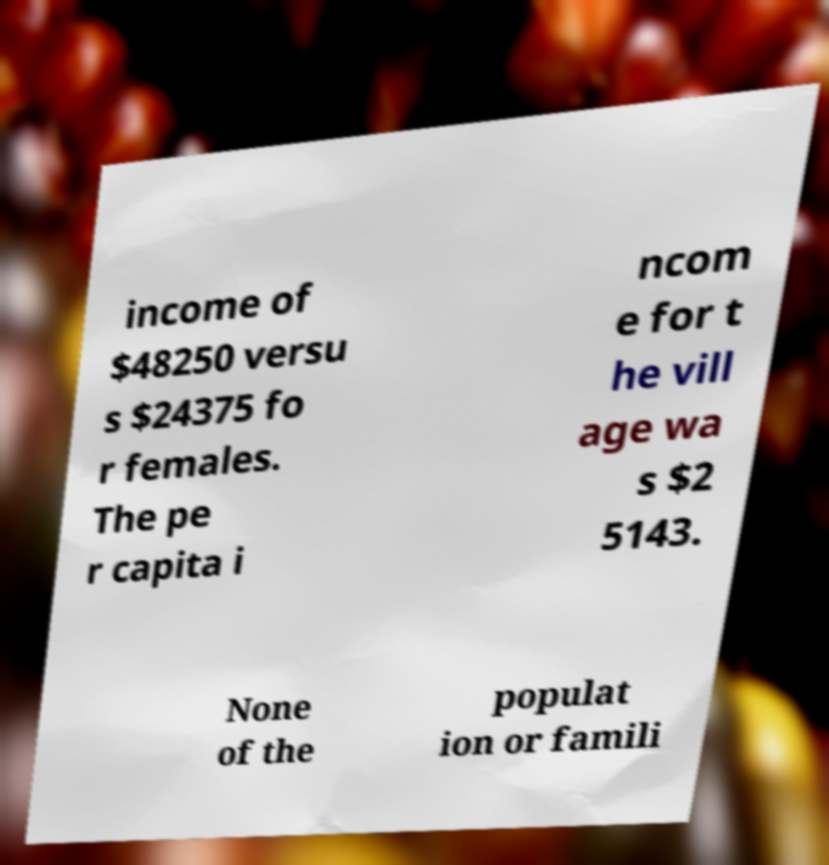Can you accurately transcribe the text from the provided image for me? income of $48250 versu s $24375 fo r females. The pe r capita i ncom e for t he vill age wa s $2 5143. None of the populat ion or famili 